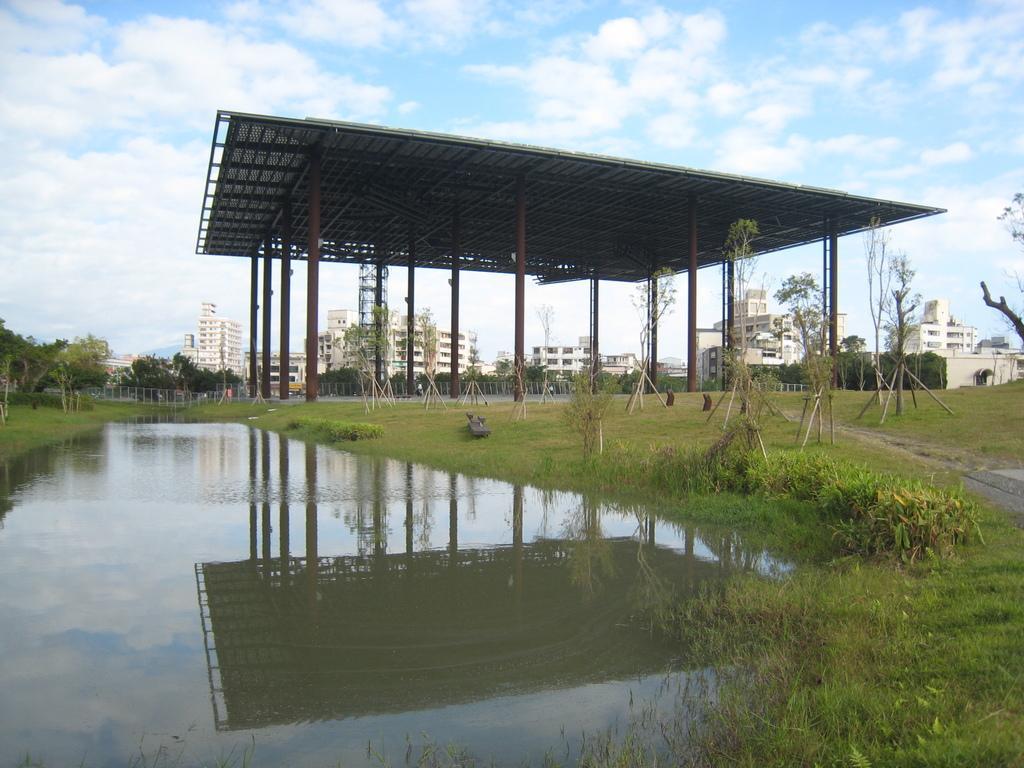How would you summarize this image in a sentence or two? In the picture I can see water, grass, trees, shed, buildings and the blue color sky with clouds in the background. 